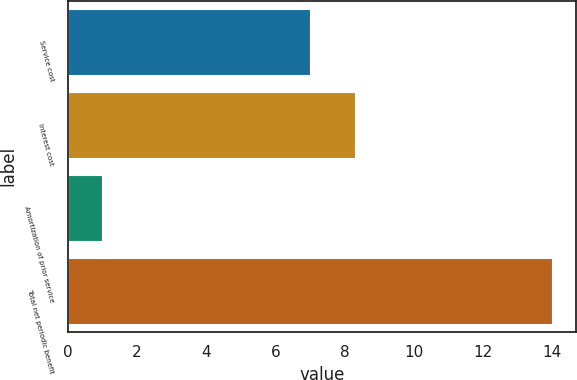Convert chart. <chart><loc_0><loc_0><loc_500><loc_500><bar_chart><fcel>Service cost<fcel>Interest cost<fcel>Amortization of prior service<fcel>Total net periodic benefit<nl><fcel>7<fcel>8.3<fcel>1<fcel>14<nl></chart> 